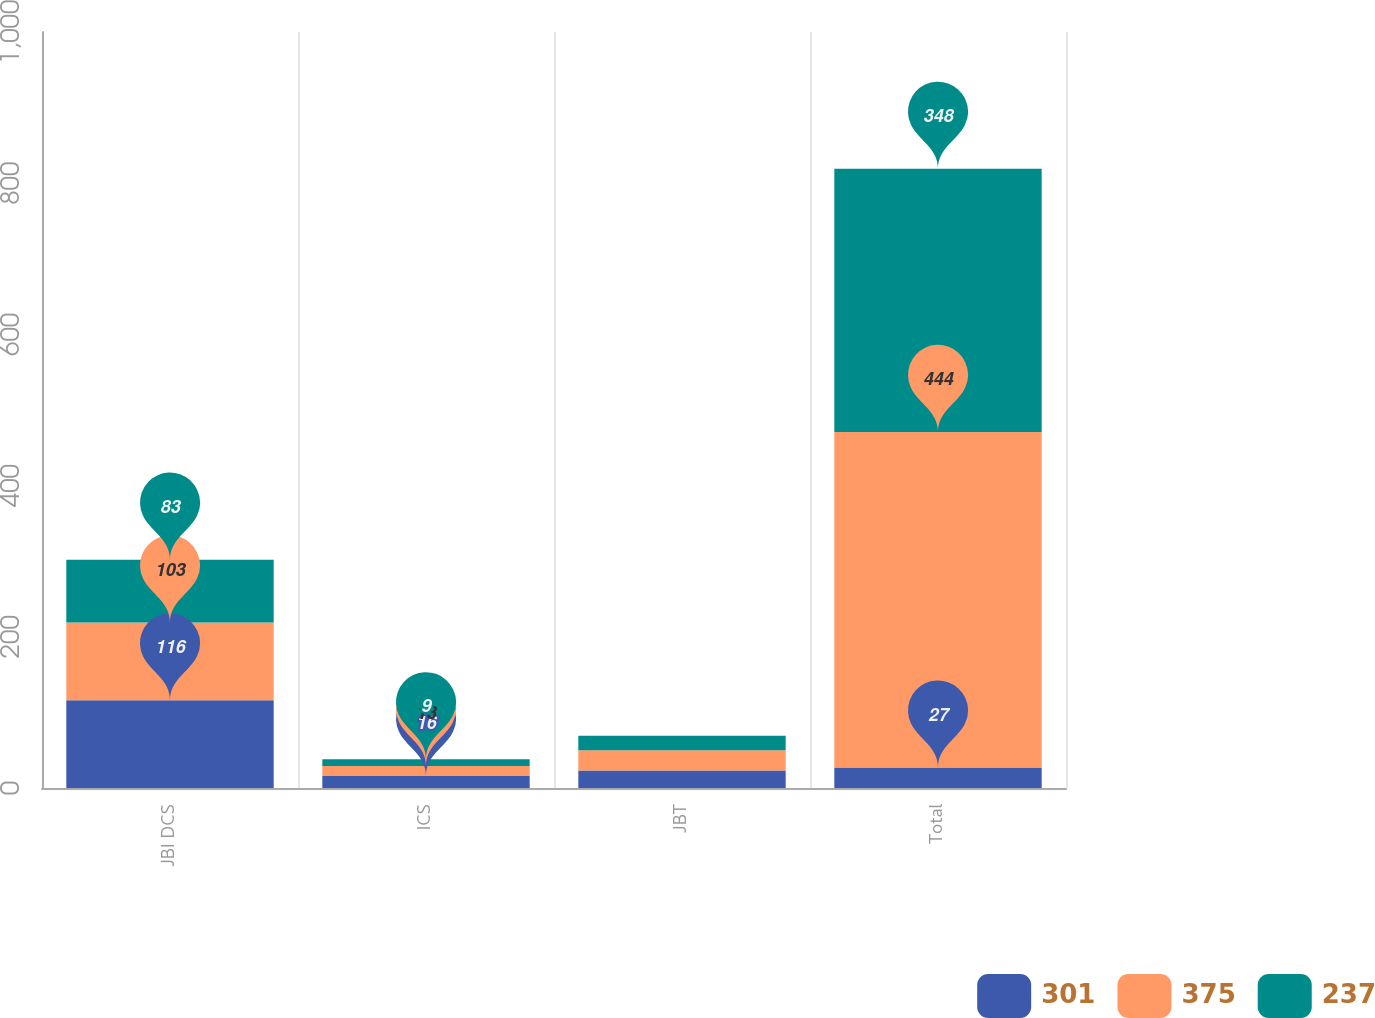Convert chart. <chart><loc_0><loc_0><loc_500><loc_500><stacked_bar_chart><ecel><fcel>JBI DCS<fcel>ICS<fcel>JBT<fcel>Total<nl><fcel>301<fcel>116<fcel>16<fcel>23<fcel>27<nl><fcel>375<fcel>103<fcel>13<fcel>27<fcel>444<nl><fcel>237<fcel>83<fcel>9<fcel>19<fcel>348<nl></chart> 